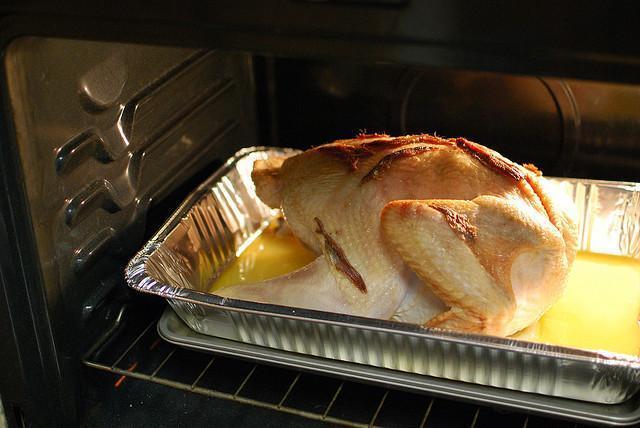How many giraffe are behind the fence?
Give a very brief answer. 0. 